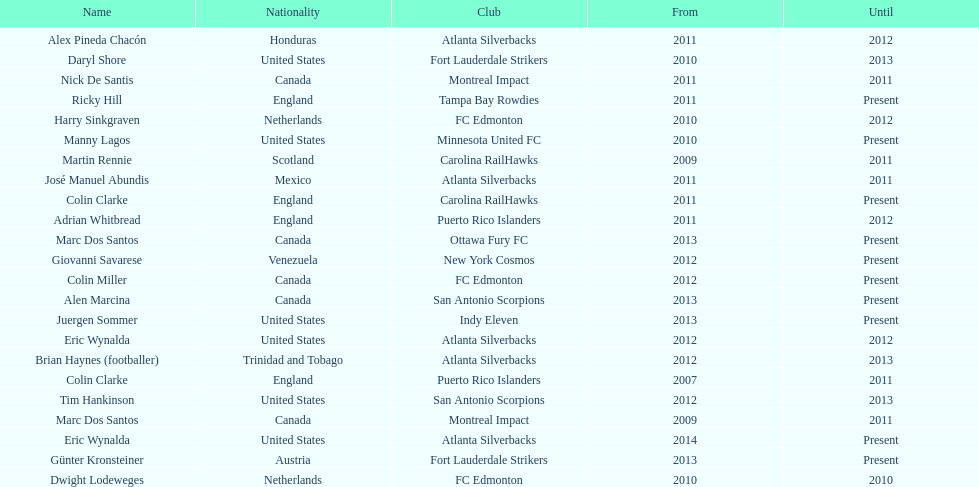How long did colin clarke coach the puerto rico islanders for? 4 years. 